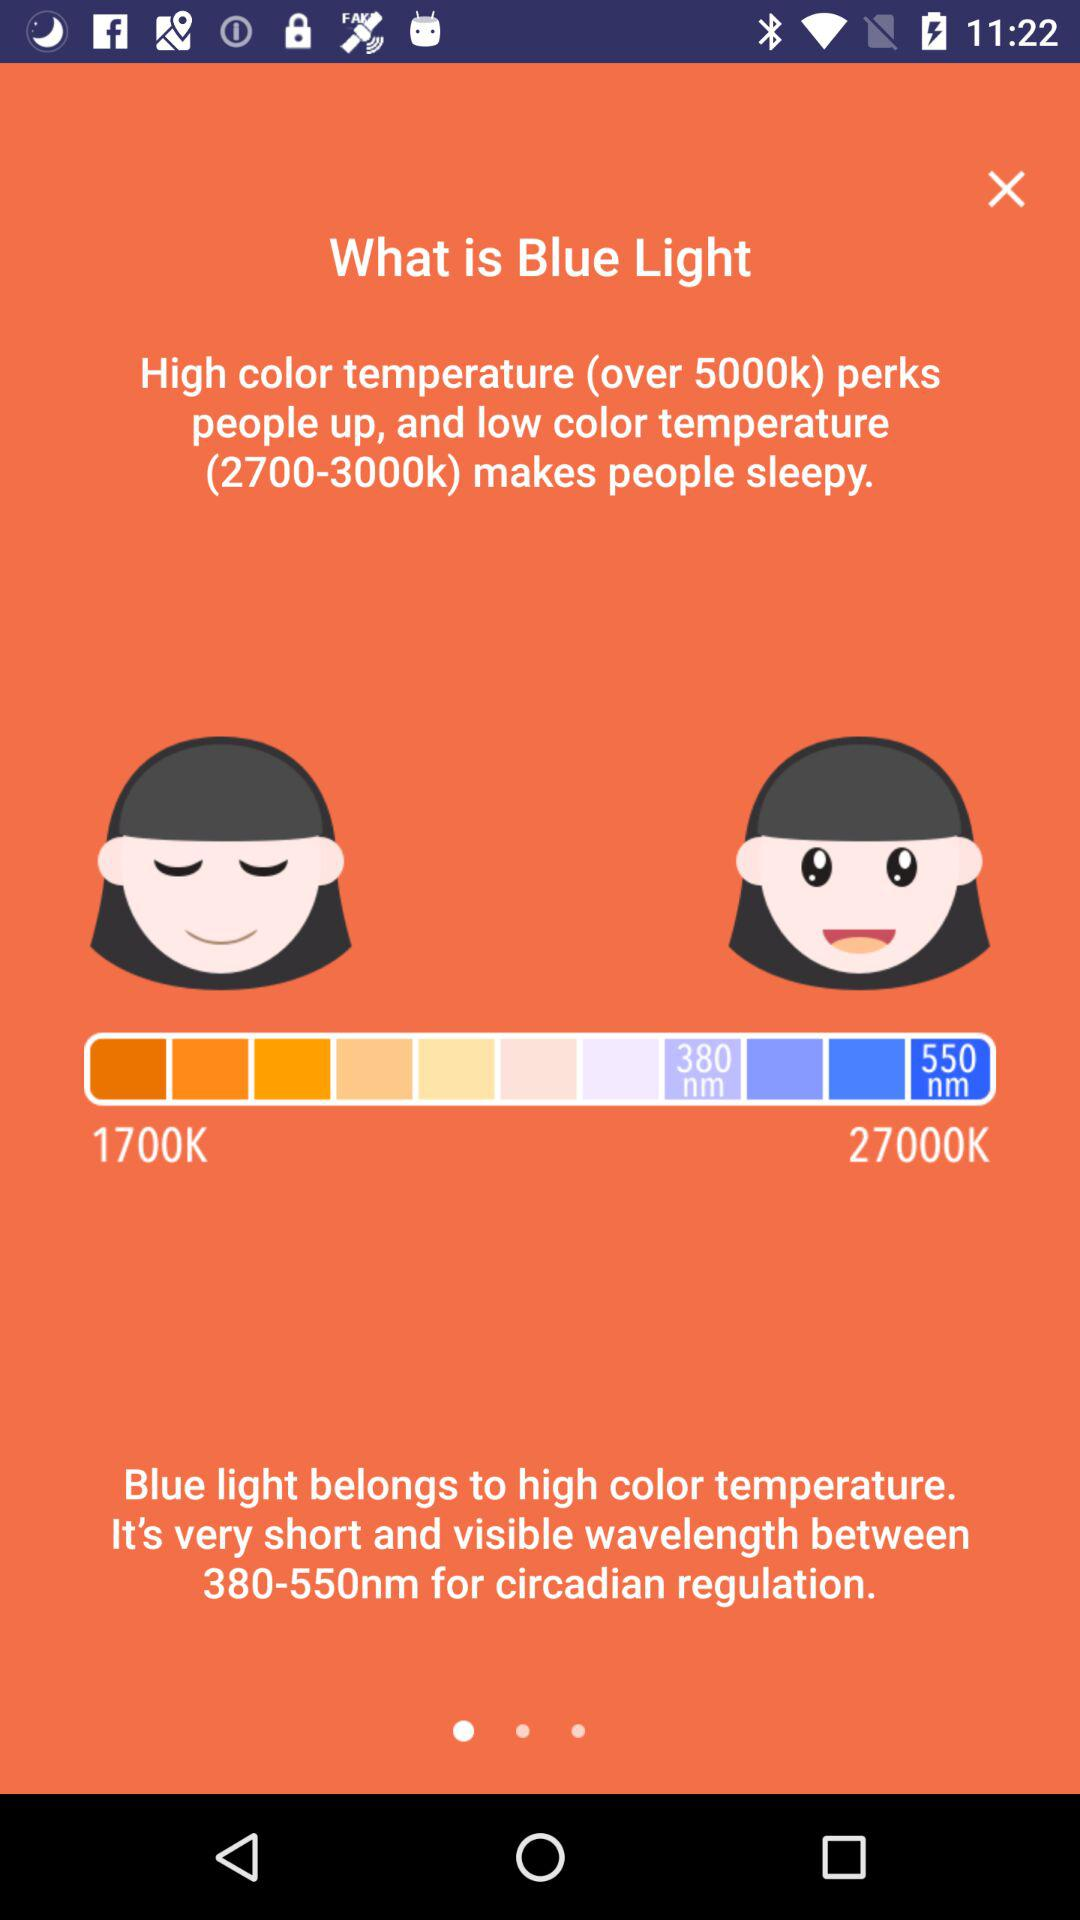What temperature does blue light belongs to? Blue light belongs to the high color temperature. 